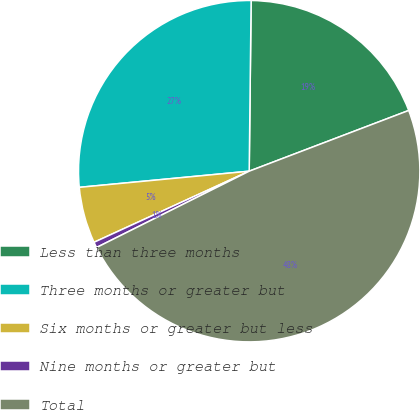<chart> <loc_0><loc_0><loc_500><loc_500><pie_chart><fcel>Less than three months<fcel>Three months or greater but<fcel>Six months or greater but less<fcel>Nine months or greater but<fcel>Total<nl><fcel>19.03%<fcel>26.69%<fcel>5.33%<fcel>0.54%<fcel>48.41%<nl></chart> 